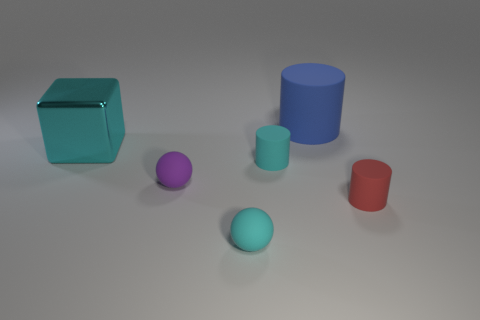Subtract all purple blocks. Subtract all gray balls. How many blocks are left? 1 Add 2 big green rubber things. How many objects exist? 8 Subtract all spheres. How many objects are left? 4 Add 3 tiny red rubber objects. How many tiny red rubber objects exist? 4 Subtract 1 cyan cylinders. How many objects are left? 5 Subtract all blue objects. Subtract all large cyan shiny objects. How many objects are left? 4 Add 4 cyan things. How many cyan things are left? 7 